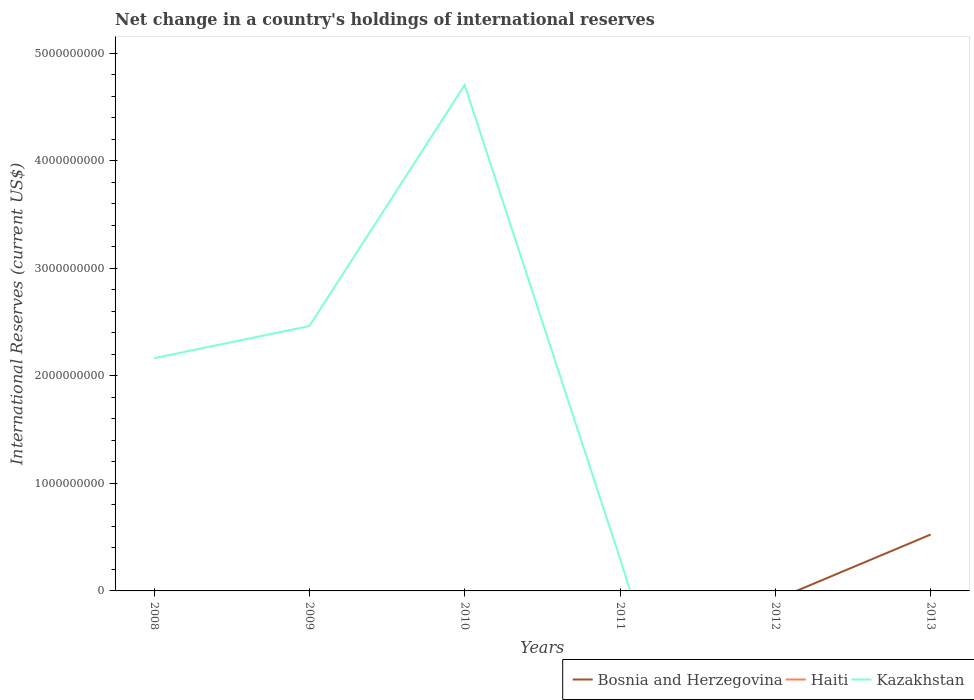Does the line corresponding to Kazakhstan intersect with the line corresponding to Haiti?
Provide a succinct answer. Yes. Is the number of lines equal to the number of legend labels?
Your answer should be compact. No. Across all years, what is the maximum international reserves in Kazakhstan?
Keep it short and to the point. 0. What is the total international reserves in Kazakhstan in the graph?
Provide a short and direct response. 4.41e+09. What is the difference between the highest and the second highest international reserves in Kazakhstan?
Make the answer very short. 4.71e+09. What is the difference between the highest and the lowest international reserves in Kazakhstan?
Your response must be concise. 3. Is the international reserves in Haiti strictly greater than the international reserves in Bosnia and Herzegovina over the years?
Give a very brief answer. Yes. How many lines are there?
Your answer should be compact. 2. Does the graph contain any zero values?
Make the answer very short. Yes. Does the graph contain grids?
Give a very brief answer. No. How are the legend labels stacked?
Provide a short and direct response. Horizontal. What is the title of the graph?
Make the answer very short. Net change in a country's holdings of international reserves. What is the label or title of the Y-axis?
Your response must be concise. International Reserves (current US$). What is the International Reserves (current US$) of Bosnia and Herzegovina in 2008?
Keep it short and to the point. 0. What is the International Reserves (current US$) of Kazakhstan in 2008?
Ensure brevity in your answer.  2.17e+09. What is the International Reserves (current US$) of Kazakhstan in 2009?
Make the answer very short. 2.46e+09. What is the International Reserves (current US$) in Bosnia and Herzegovina in 2010?
Your answer should be very brief. 0. What is the International Reserves (current US$) in Haiti in 2010?
Ensure brevity in your answer.  0. What is the International Reserves (current US$) of Kazakhstan in 2010?
Your answer should be very brief. 4.71e+09. What is the International Reserves (current US$) in Bosnia and Herzegovina in 2011?
Provide a succinct answer. 0. What is the International Reserves (current US$) in Haiti in 2011?
Give a very brief answer. 0. What is the International Reserves (current US$) in Kazakhstan in 2011?
Keep it short and to the point. 3.00e+08. What is the International Reserves (current US$) in Bosnia and Herzegovina in 2012?
Your answer should be very brief. 0. What is the International Reserves (current US$) in Kazakhstan in 2012?
Your answer should be compact. 0. What is the International Reserves (current US$) of Bosnia and Herzegovina in 2013?
Provide a short and direct response. 5.24e+08. What is the International Reserves (current US$) in Haiti in 2013?
Provide a succinct answer. 0. What is the International Reserves (current US$) in Kazakhstan in 2013?
Keep it short and to the point. 0. Across all years, what is the maximum International Reserves (current US$) in Bosnia and Herzegovina?
Offer a terse response. 5.24e+08. Across all years, what is the maximum International Reserves (current US$) in Kazakhstan?
Your answer should be compact. 4.71e+09. What is the total International Reserves (current US$) of Bosnia and Herzegovina in the graph?
Offer a very short reply. 5.24e+08. What is the total International Reserves (current US$) in Kazakhstan in the graph?
Ensure brevity in your answer.  9.64e+09. What is the difference between the International Reserves (current US$) in Kazakhstan in 2008 and that in 2009?
Provide a short and direct response. -2.99e+08. What is the difference between the International Reserves (current US$) in Kazakhstan in 2008 and that in 2010?
Offer a very short reply. -2.54e+09. What is the difference between the International Reserves (current US$) of Kazakhstan in 2008 and that in 2011?
Provide a short and direct response. 1.86e+09. What is the difference between the International Reserves (current US$) in Kazakhstan in 2009 and that in 2010?
Offer a terse response. -2.24e+09. What is the difference between the International Reserves (current US$) of Kazakhstan in 2009 and that in 2011?
Provide a short and direct response. 2.16e+09. What is the difference between the International Reserves (current US$) of Kazakhstan in 2010 and that in 2011?
Your answer should be compact. 4.41e+09. What is the average International Reserves (current US$) in Bosnia and Herzegovina per year?
Ensure brevity in your answer.  8.74e+07. What is the average International Reserves (current US$) in Kazakhstan per year?
Your answer should be compact. 1.61e+09. What is the ratio of the International Reserves (current US$) of Kazakhstan in 2008 to that in 2009?
Give a very brief answer. 0.88. What is the ratio of the International Reserves (current US$) of Kazakhstan in 2008 to that in 2010?
Provide a short and direct response. 0.46. What is the ratio of the International Reserves (current US$) of Kazakhstan in 2008 to that in 2011?
Offer a very short reply. 7.21. What is the ratio of the International Reserves (current US$) in Kazakhstan in 2009 to that in 2010?
Offer a very short reply. 0.52. What is the ratio of the International Reserves (current US$) of Kazakhstan in 2009 to that in 2011?
Provide a succinct answer. 8.2. What is the ratio of the International Reserves (current US$) of Kazakhstan in 2010 to that in 2011?
Provide a short and direct response. 15.66. What is the difference between the highest and the second highest International Reserves (current US$) in Kazakhstan?
Give a very brief answer. 2.24e+09. What is the difference between the highest and the lowest International Reserves (current US$) of Bosnia and Herzegovina?
Ensure brevity in your answer.  5.24e+08. What is the difference between the highest and the lowest International Reserves (current US$) in Kazakhstan?
Provide a succinct answer. 4.71e+09. 